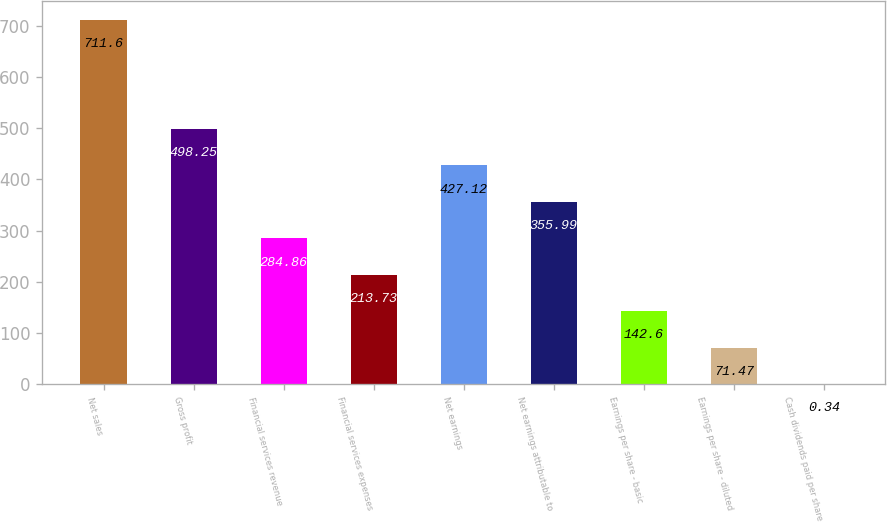Convert chart. <chart><loc_0><loc_0><loc_500><loc_500><bar_chart><fcel>Net sales<fcel>Gross profit<fcel>Financial services revenue<fcel>Financial services expenses<fcel>Net earnings<fcel>Net earnings attributable to<fcel>Earnings per share - basic<fcel>Earnings per share - diluted<fcel>Cash dividends paid per share<nl><fcel>711.6<fcel>498.25<fcel>284.86<fcel>213.73<fcel>427.12<fcel>355.99<fcel>142.6<fcel>71.47<fcel>0.34<nl></chart> 